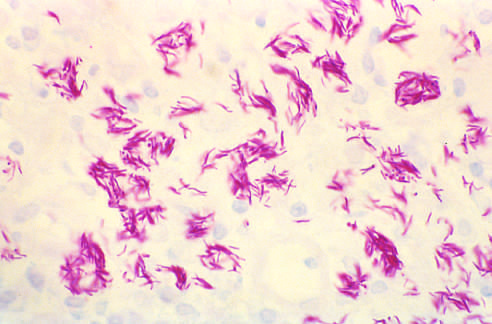what does mycobacterium avium infection in a duodenal biopsy from a patient with aids show?
Answer the question using a single word or phrase. Massive intracellular macrophage infection with acid-fast organisms 